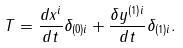Convert formula to latex. <formula><loc_0><loc_0><loc_500><loc_500>T = \frac { d x ^ { i } } { d t } \delta _ { ( 0 ) i } + \frac { \delta y ^ { ( 1 ) i } } { d t } \delta _ { ( 1 ) i } .</formula> 